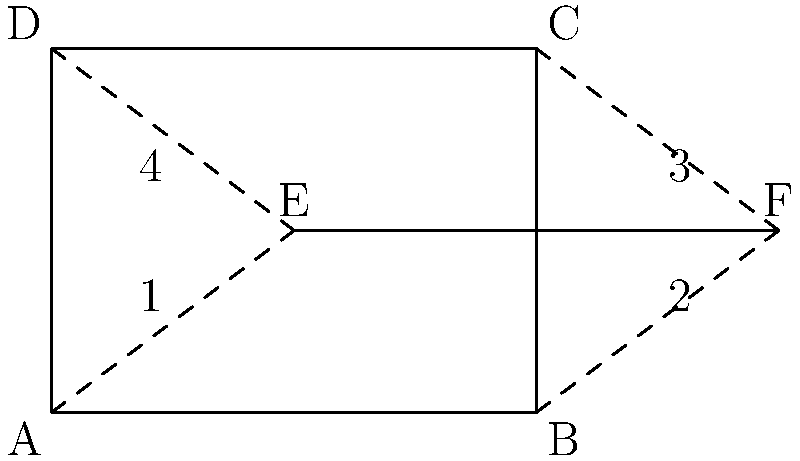In the airport terminal layout shown above, which pair of angles are congruent? To determine which pair of angles are congruent, we need to analyze the given diagram and apply our knowledge of congruent angles. Let's follow these steps:

1. Observe that the diagram shows a rectangle ABCD representing the airport terminal.
2. Line EF is drawn parallel to sides AB and DC of the rectangle.
3. When a line is drawn parallel to one side of a rectangle, it creates congruent angles with the adjacent sides.
4. In this case, line EF creates four angles with the sides of the rectangle: 1, 2, 3, and 4.
5. Angles formed by a transversal (EF) crossing parallel lines (AB and DC) have special relationships:
   - Corresponding angles are congruent
   - Alternate interior angles are congruent
   - Alternate exterior angles are congruent
6. In this diagram:
   - Angles 1 and 3 are alternate interior angles
   - Angles 2 and 4 are alternate interior angles
7. Therefore, we can conclude that:
   - Angle 1 is congruent to angle 3
   - Angle 2 is congruent to angle 4

Thus, there are two pairs of congruent angles: (1,3) and (2,4). However, the question asks for a single pair, so either answer would be correct.
Answer: Angles 1 and 3 